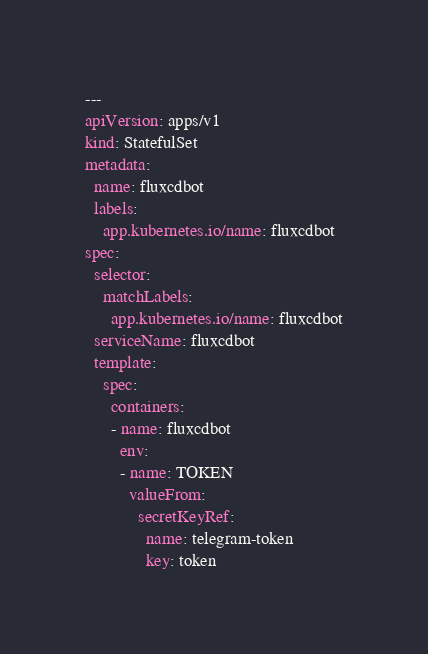<code> <loc_0><loc_0><loc_500><loc_500><_YAML_>---
apiVersion: apps/v1
kind: StatefulSet
metadata:
  name: fluxcdbot
  labels:
    app.kubernetes.io/name: fluxcdbot
spec:
  selector:
    matchLabels:
      app.kubernetes.io/name: fluxcdbot
  serviceName: fluxcdbot
  template:
    spec:
      containers:
      - name: fluxcdbot
        env:
        - name: TOKEN
          valueFrom:
            secretKeyRef:
              name: telegram-token
              key: token
</code> 